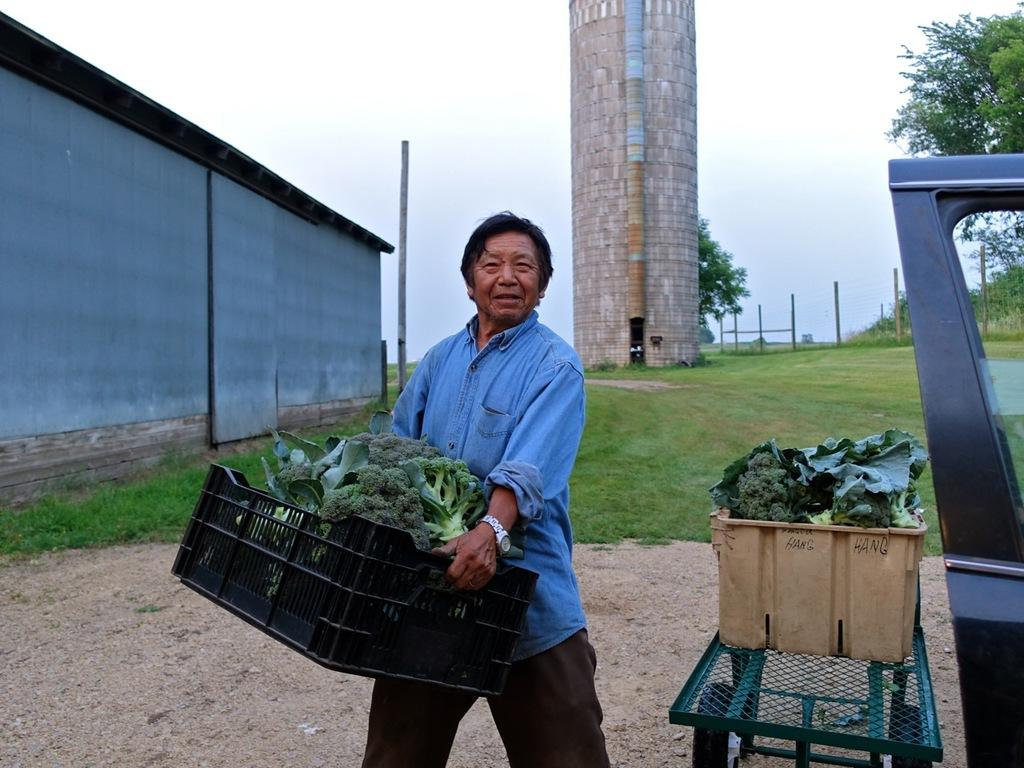What is the person in the image holding? The person is holding a basket in the image. What can be found inside the basket? There is an object in the basket. What structures can be seen in the background of the image? There is a house and a tower in the background of the image. Can you describe the sky in the image? The sky is visible in the image, and it has a white and blue color. Are there any other baskets visible in the image? Yes, there is another basket on a table in the background of the image. How does the person in the image plan to embark on their voyage using the stone? There is no stone or voyage mentioned in the image; the person is holding a basket with an object inside. 